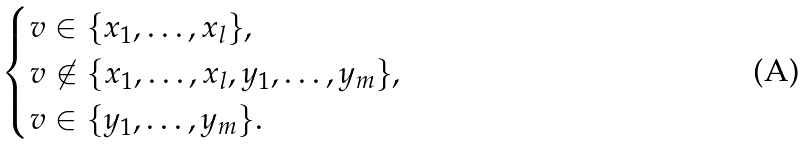Convert formula to latex. <formula><loc_0><loc_0><loc_500><loc_500>\begin{cases} v \in \{ x _ { 1 } , \dots , x _ { l } \} , \\ v \not \in \{ x _ { 1 } , \dots , x _ { l } , y _ { 1 } , \dots , y _ { m } \} , \\ v \in \{ y _ { 1 } , \dots , y _ { m } \} . \\ \end{cases}</formula> 